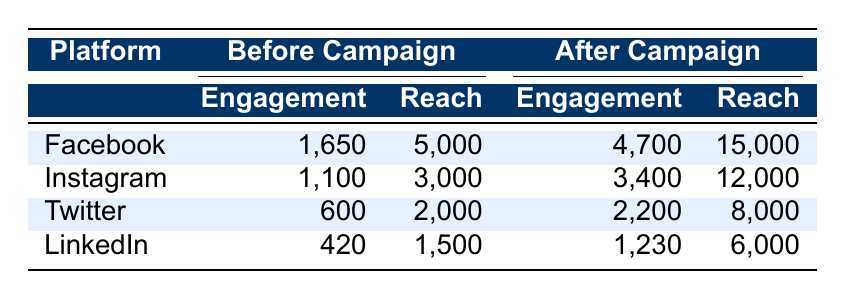What was the total engagement on Facebook before the campaign? The engagement on Facebook before the campaign comprises likes, shares, and comments. According to the table, the values are 1200 likes + 300 shares + 150 comments = 1650 total engagement.
Answer: 1650 What was the post reach on Twitter after the campaign? Referring to the table, the post reach for Twitter after the campaign is stated directly as 8000.
Answer: 8000 Did the number of shares on Instagram increase after the campaign? The number of shares on Instagram was 200 before the campaign and became 600 after the campaign. Since 600 is greater than 200, the shares did increase.
Answer: Yes What is the percentage increase in likes on Facebook after the campaign? The likes on Facebook increased from 1200 to 3500. To find the percentage increase, use the formula: [(3500 - 1200) / 1200] * 100 = (2300 / 1200) * 100 ≈ 191.67%.
Answer: Approximately 191.67% Which platform had the highest engagement after the campaign? Looking at the after-campaign engagement values, Facebook had 4700, Instagram had 3400, Twitter had 2200, and LinkedIn had 1230. Therefore, Facebook had the highest engagement value of 4700.
Answer: Facebook What is the average post reach across all platforms before the campaign? The post reach before the campaign is: Facebook (5000) + Instagram (3000) + Twitter (2000) + LinkedIn (1500) = 11500. To find the average, divide this sum by the number of platforms (4): 11500 / 4 = 2875.
Answer: 2875 Is it true that LinkedIn's engagement after the campaign was less than Instagram's engagement after the campaign? After the campaign, LinkedIn's engagement was 1230 and Instagram's engagement was 3400. Since 1230 is less than 3400, the statement is true.
Answer: Yes What is the difference in comments between before and after the campaign for Twitter? For Twitter, the comments before the campaign were 50 and increased to 200 after. The difference would be: 200 - 50 = 150.
Answer: 150 Which platform saw the greatest increase in post reach? The post reach increased from 5000 to 15000 for Facebook, from 3000 to 12000 for Instagram, from 2000 to 8000 for Twitter, and from 1500 to 6000 for LinkedIn. The increase for Facebook is 10000, for Instagram is 9000, for Twitter is 6000, and for LinkedIn is 4500. The greatest increase was thus seen in Facebook.
Answer: Facebook 